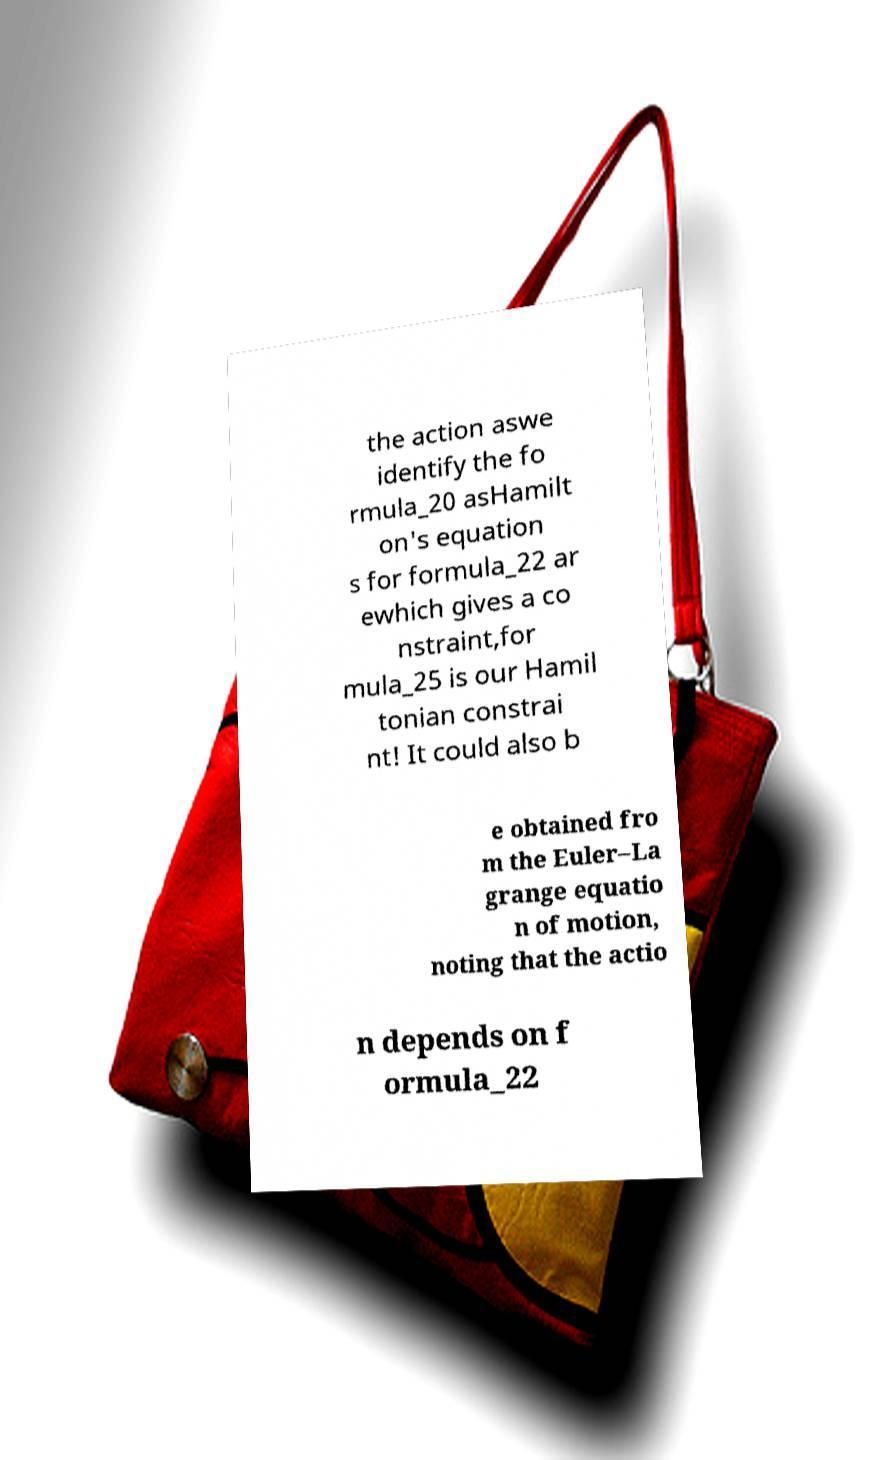Can you read and provide the text displayed in the image?This photo seems to have some interesting text. Can you extract and type it out for me? the action aswe identify the fo rmula_20 asHamilt on's equation s for formula_22 ar ewhich gives a co nstraint,for mula_25 is our Hamil tonian constrai nt! It could also b e obtained fro m the Euler–La grange equatio n of motion, noting that the actio n depends on f ormula_22 